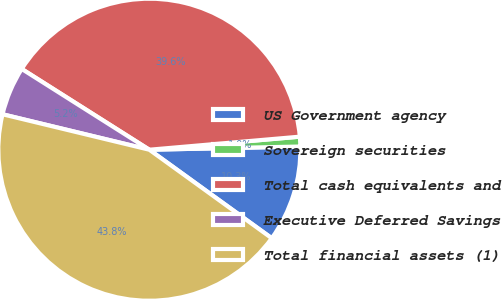Convert chart. <chart><loc_0><loc_0><loc_500><loc_500><pie_chart><fcel>US Government agency<fcel>Sovereign securities<fcel>Total cash equivalents and<fcel>Executive Deferred Savings<fcel>Total financial assets (1)<nl><fcel>10.3%<fcel>1.04%<fcel>39.64%<fcel>5.21%<fcel>43.81%<nl></chart> 